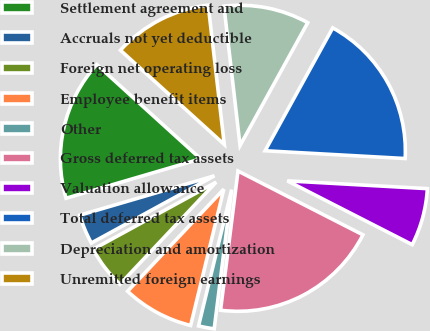<chart> <loc_0><loc_0><loc_500><loc_500><pie_chart><fcel>Settlement agreement and<fcel>Accruals not yet deductible<fcel>Foreign net operating loss<fcel>Employee benefit items<fcel>Other<fcel>Gross deferred tax assets<fcel>Valuation allowance<fcel>Total deferred tax assets<fcel>Depreciation and amortization<fcel>Unremitted foreign earnings<nl><fcel>16.26%<fcel>3.42%<fcel>5.02%<fcel>8.23%<fcel>1.81%<fcel>19.47%<fcel>6.63%<fcel>17.87%<fcel>9.84%<fcel>11.44%<nl></chart> 